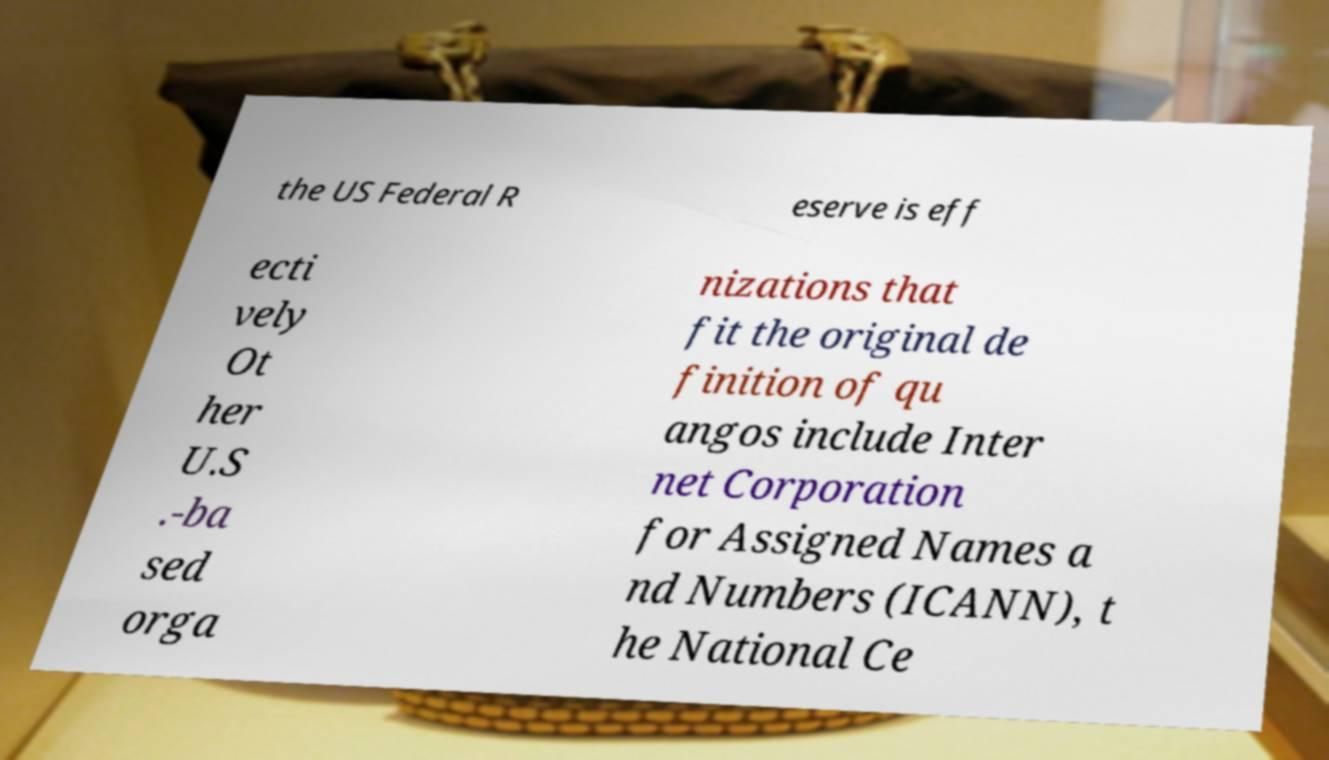Could you extract and type out the text from this image? the US Federal R eserve is eff ecti vely Ot her U.S .-ba sed orga nizations that fit the original de finition of qu angos include Inter net Corporation for Assigned Names a nd Numbers (ICANN), t he National Ce 